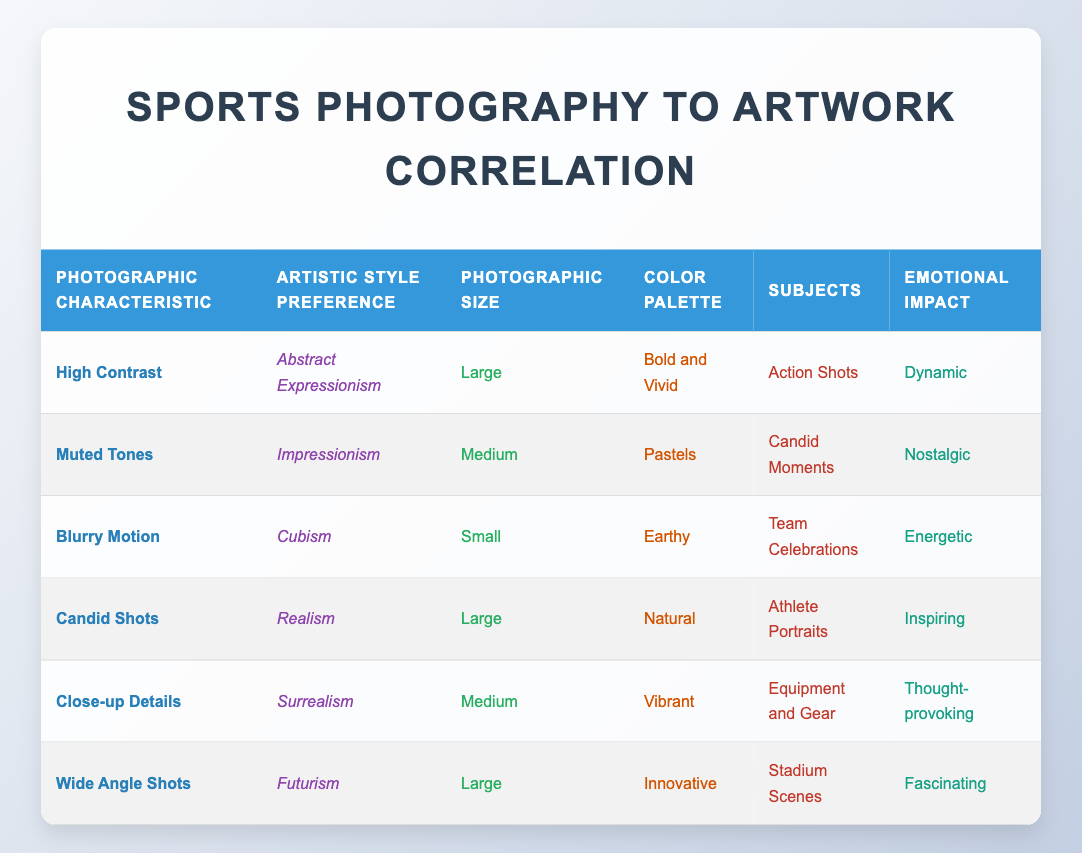What artistic style preference is associated with "High Contrast"? The table indicates that "High Contrast" is linked to the artistic style preference of "Abstract Expressionism".
Answer: Abstract Expressionism Which photographic characteristic is linked to "Nostalgic" emotional impact? Referring to the table, "Muted Tones" has an emotional impact described as "Nostalgic".
Answer: Muted Tones Which subjects are depicted in photographs characterized by "Wide Angle Shots"? According to the table, "Wide Angle Shots" are associated with the subjects "Stadium Scenes".
Answer: Stadium Scenes Is "Surrealism" preferred for photographs using a medium size? The table confirms that "Surrealism" is linked to the photographic size specified as "Medium".
Answer: Yes What is the average size of photographs used for "Abstract Expressionism" and "Realism"? From the table, "Abstract Expressionism" has a photographic size of "Large" and "Realism" also has a size of "Large". Both sizes are the same, so the average size remains "Large".
Answer: Large How many distinct emotional impacts are represented in the table? By reviewing the emotions listed for each entry, we find six distinct emotional impacts: "Dynamic", "Nostalgic", "Energetic", "Inspiring", "Thought-provoking", and "Fascinating". Thus, there are 6 unique impacts.
Answer: 6 Which color palette is utilized in "Cubism"? The table notes that the color palette for "Cubism" is "Earthy".
Answer: Earthy Are "Action Shots" commonly associated with large photographic sizes? Yes, examining the table shows that "Action Shots" are linked to the large photographic size, as it is the only entry under that subject.
Answer: Yes What emotional impact accompanies 'Blurry Motion' and how does it compare to that of 'Candid Shots'? "Blurry Motion" is paired with "Energetic" emotional impact while "Candid Shots" is associated with "Inspiring". The comparison shows that 'Blurry Motion' is more dynamic whereas 'Candid Shots' carries a motivational feeling.
Answer: Energetic is more dynamic than Inspiring 